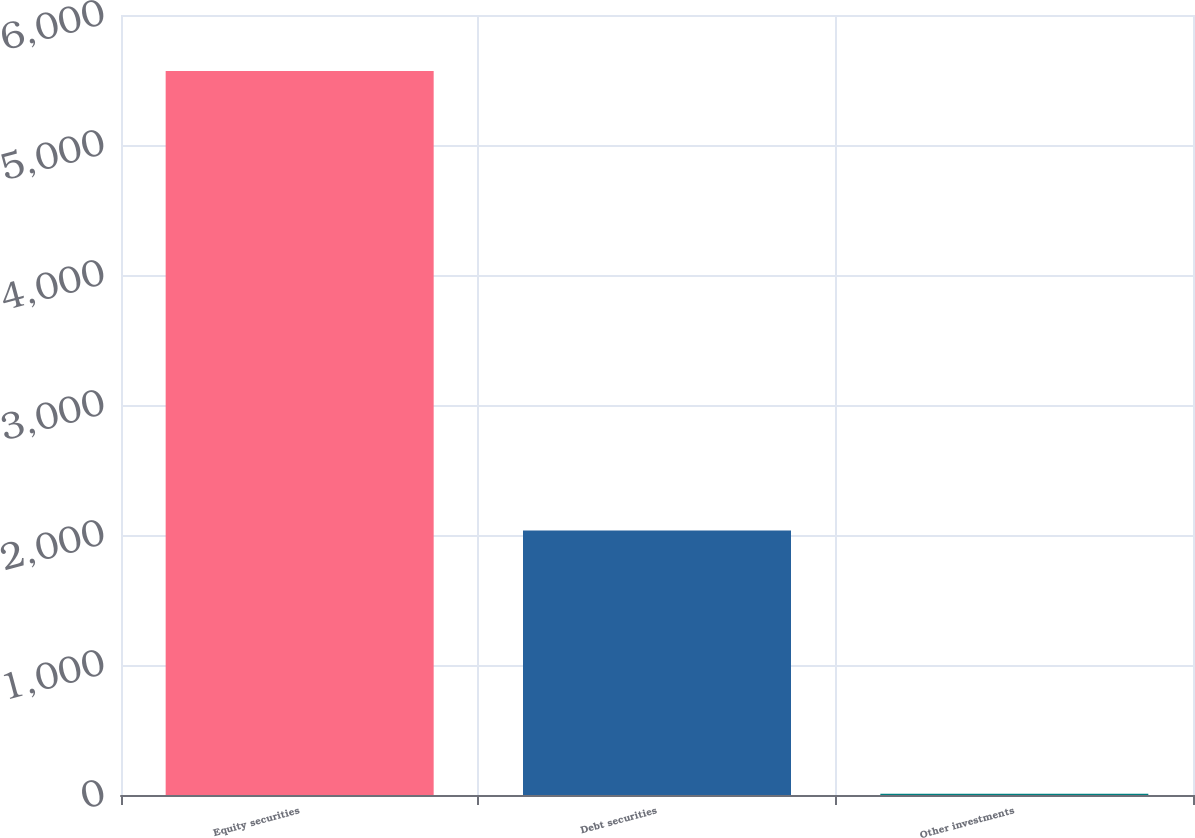Convert chart to OTSL. <chart><loc_0><loc_0><loc_500><loc_500><bar_chart><fcel>Equity securities<fcel>Debt securities<fcel>Other investments<nl><fcel>5570<fcel>2035<fcel>10<nl></chart> 